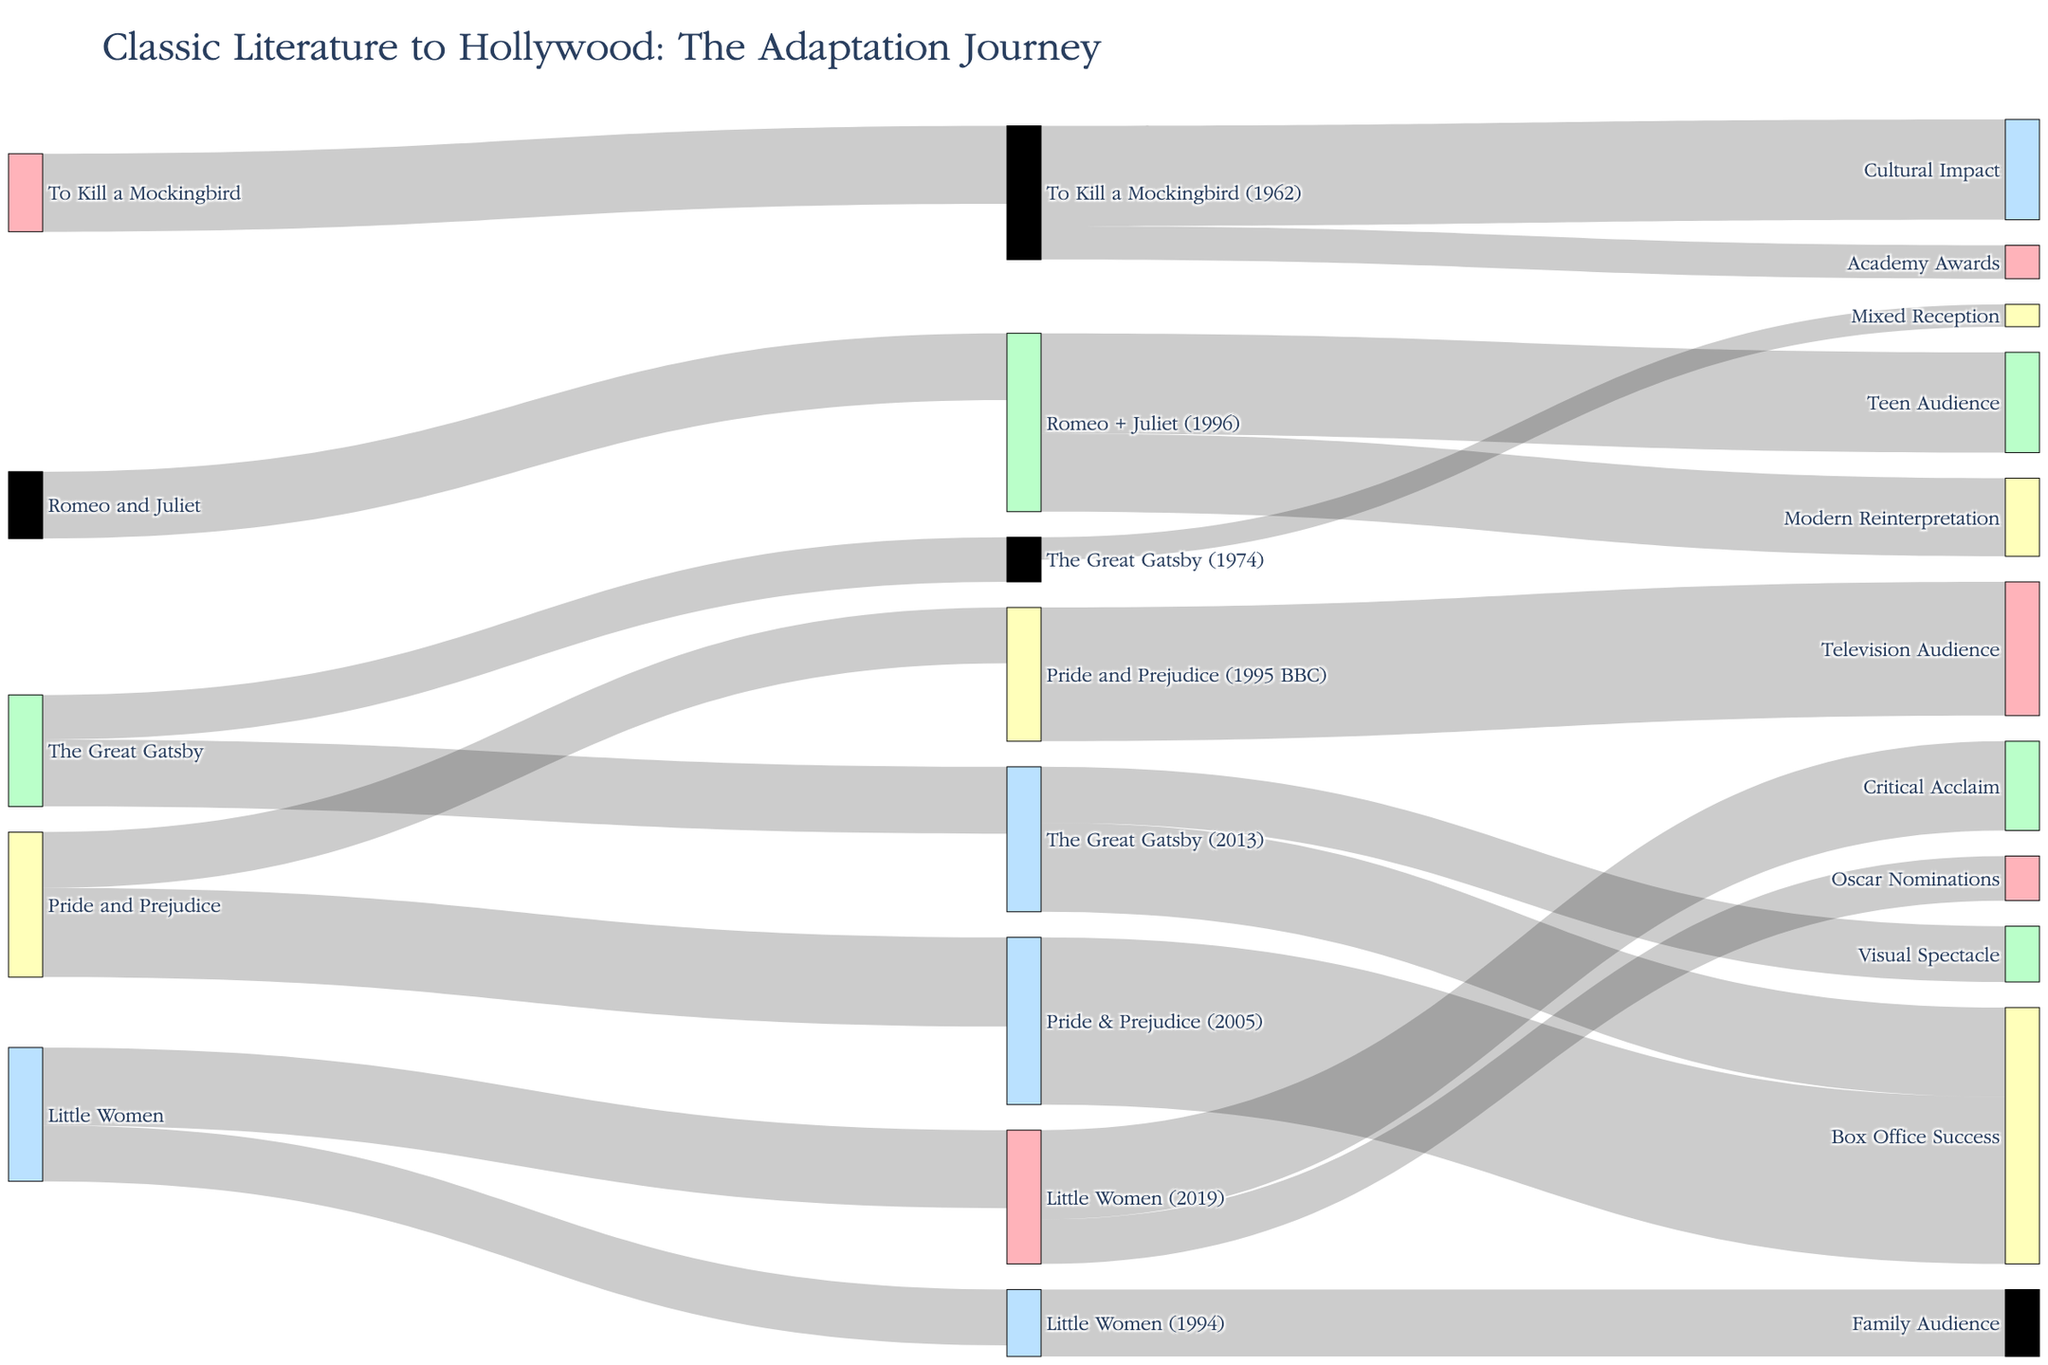How many adaptations of 'Pride and Prejudice' are visualized in the diagram? The diagram shows two adaptations flowing from 'Pride and Prejudice' to 'Pride and Prejudice (1995 BBC)' and 'Pride & Prejudice (2005)'.
Answer: Two Which adaptation of 'To Kill a Mockingbird' received Academy Awards? The flow from 'To Kill a Mockingbird (1962)' leads to 'Academy Awards'.
Answer: To Kill a Mockingbird (1962) What is the total audience reach for adaptations of ‘Pride and Prejudice’? Add the values of 'Television Audience' (12) and 'Box Office Success' (15) from 'Pride and Prejudice' adaptations. 12 + 15 = 27.
Answer: 27 What Hollywood adaptation of 'Little Women' received critical acclaim? The diagram shows that the flow from 'Little Women (2019)' leads to 'Critical Acclaim’.
Answer: Little Women (2019) Which adaptations of 'The Great Gatsby' had disparate receptions and what were they? 'The Great Gatsby (1974)' received 'Mixed Reception', while 'The Great Gatsby (2013)' had 'Visual Spectacle' and 'Box Office Success'.
Answer: The Great Gatsby (1974): Mixed Reception, The Great Gatsby (2013): Visual Spectacle, Box Office Success How successful was 'Romeo + Juliet (1996)' among audience categories and what categories did it appeal to? The adaptation pleased 'Teen Audience' (9) and was classified as a 'Modern Reinterpretation' (7).
Answer: Teen Audience, Modern Reinterpretation Which Hollywood adaptation has a higher value for cultural impact: 'Pride and Prejudice (1995 BBC)' or 'To Kill a Mockingbird (1962)'? Cultural Impact value for 'To Kill a Mockingbird (1962)' is 9. The 'Pride and Prejudice (1995 BBC)' does not connect to cultural impact but to Television Audience.
Answer: To Kill a Mockingbird (1962) What is the sum value of ALL adaptations listed under 'Little Women' flowing to their targets? Sum the values: 'Little Women (1994)' to 'Family Audience' (6) and 'Little Women (2019)' to 'Critical Acclaim' (8) and 'Oscar Nominations' (4). 6 + 8 + 4 = 18.
Answer: 18 What concludes more often, box office or critical success for Hollywood adaptations? The diagram shows 'Box Office Success' for 'Pride & Prejudice (2005)' and 'The Great Gatsby (2013)', whereas 'Critical Acclaim' appears only for 'Little Women (2019)'.
Answer: Box Office How many books in total have been adapted into films and their subsequent impacts in the diagram? Counting the unique source books: 'Pride and Prejudice', 'To Kill a Mockingbird', 'The Great Gatsby', 'Romeo and Juliet', and 'Little Women'. There are 5 unique books.
Answer: 5 